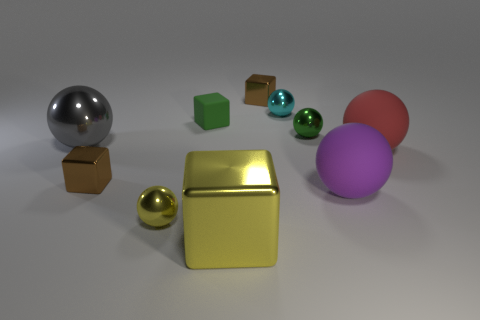Are the small brown cube to the left of the yellow ball and the green ball made of the same material?
Provide a short and direct response. Yes. What number of things are either gray shiny things or blocks that are behind the purple matte ball?
Your answer should be compact. 4. There is a red thing that is the same shape as the tiny yellow metal object; what size is it?
Make the answer very short. Large. Is there anything else that has the same size as the cyan metallic sphere?
Your answer should be very brief. Yes. There is a gray metal object; are there any yellow shiny objects in front of it?
Provide a succinct answer. Yes. There is a small metallic object that is in front of the large purple matte thing; does it have the same color as the tiny object right of the tiny cyan ball?
Keep it short and to the point. No. Are there any tiny cyan metallic objects of the same shape as the big yellow object?
Your answer should be very brief. No. What number of other objects are there of the same color as the tiny rubber thing?
Offer a terse response. 1. What color is the metal cube on the left side of the large metal object that is in front of the brown object in front of the large gray object?
Offer a very short reply. Brown. Are there the same number of small cubes that are on the left side of the yellow metallic cube and matte objects?
Keep it short and to the point. No. 